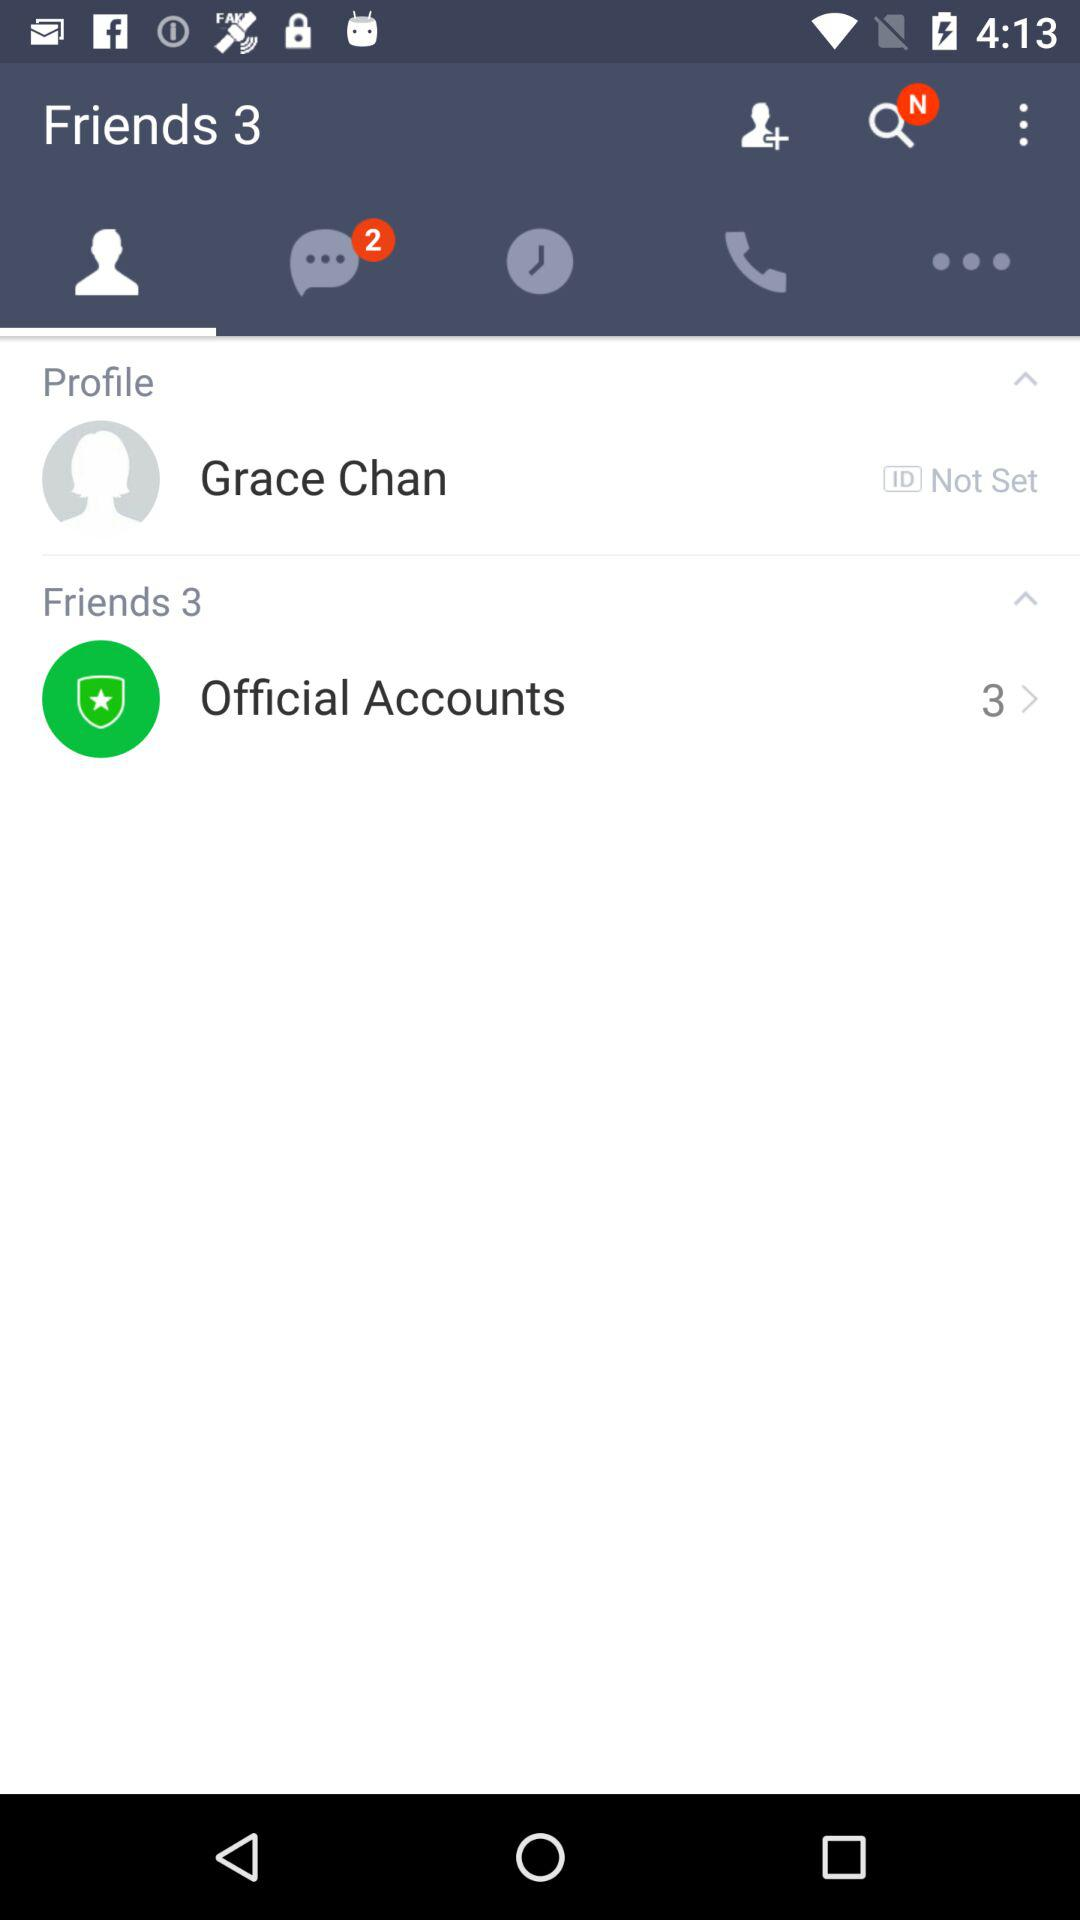How many official accounts are there? There are 3 official accounts. 